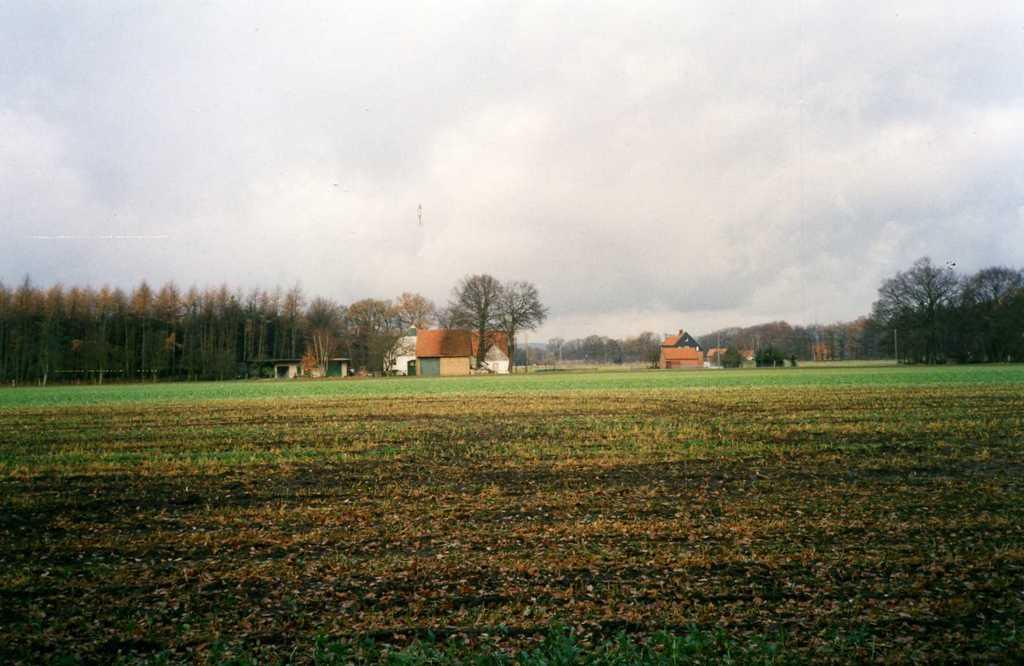How would you summarize this image in a sentence or two? In this image I can see the ground. In the background I can see the houses which are in brown color. I can also see many trees, cloud and sky in the back. 